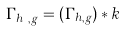<formula> <loc_0><loc_0><loc_500><loc_500>\Gamma _ { h ^ { k } , g } = ( \Gamma _ { h , g } ) * k</formula> 